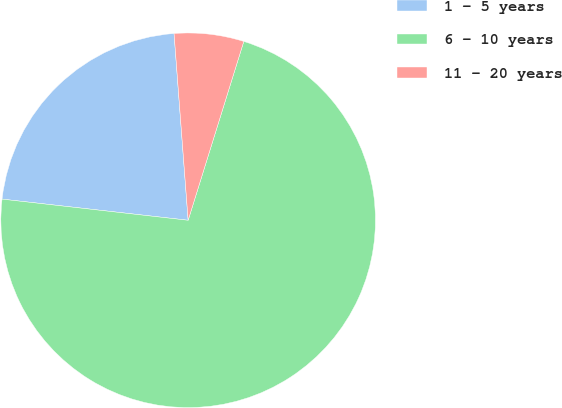Convert chart to OTSL. <chart><loc_0><loc_0><loc_500><loc_500><pie_chart><fcel>1 - 5 years<fcel>6 - 10 years<fcel>11 - 20 years<nl><fcel>22.0%<fcel>72.0%<fcel>6.0%<nl></chart> 